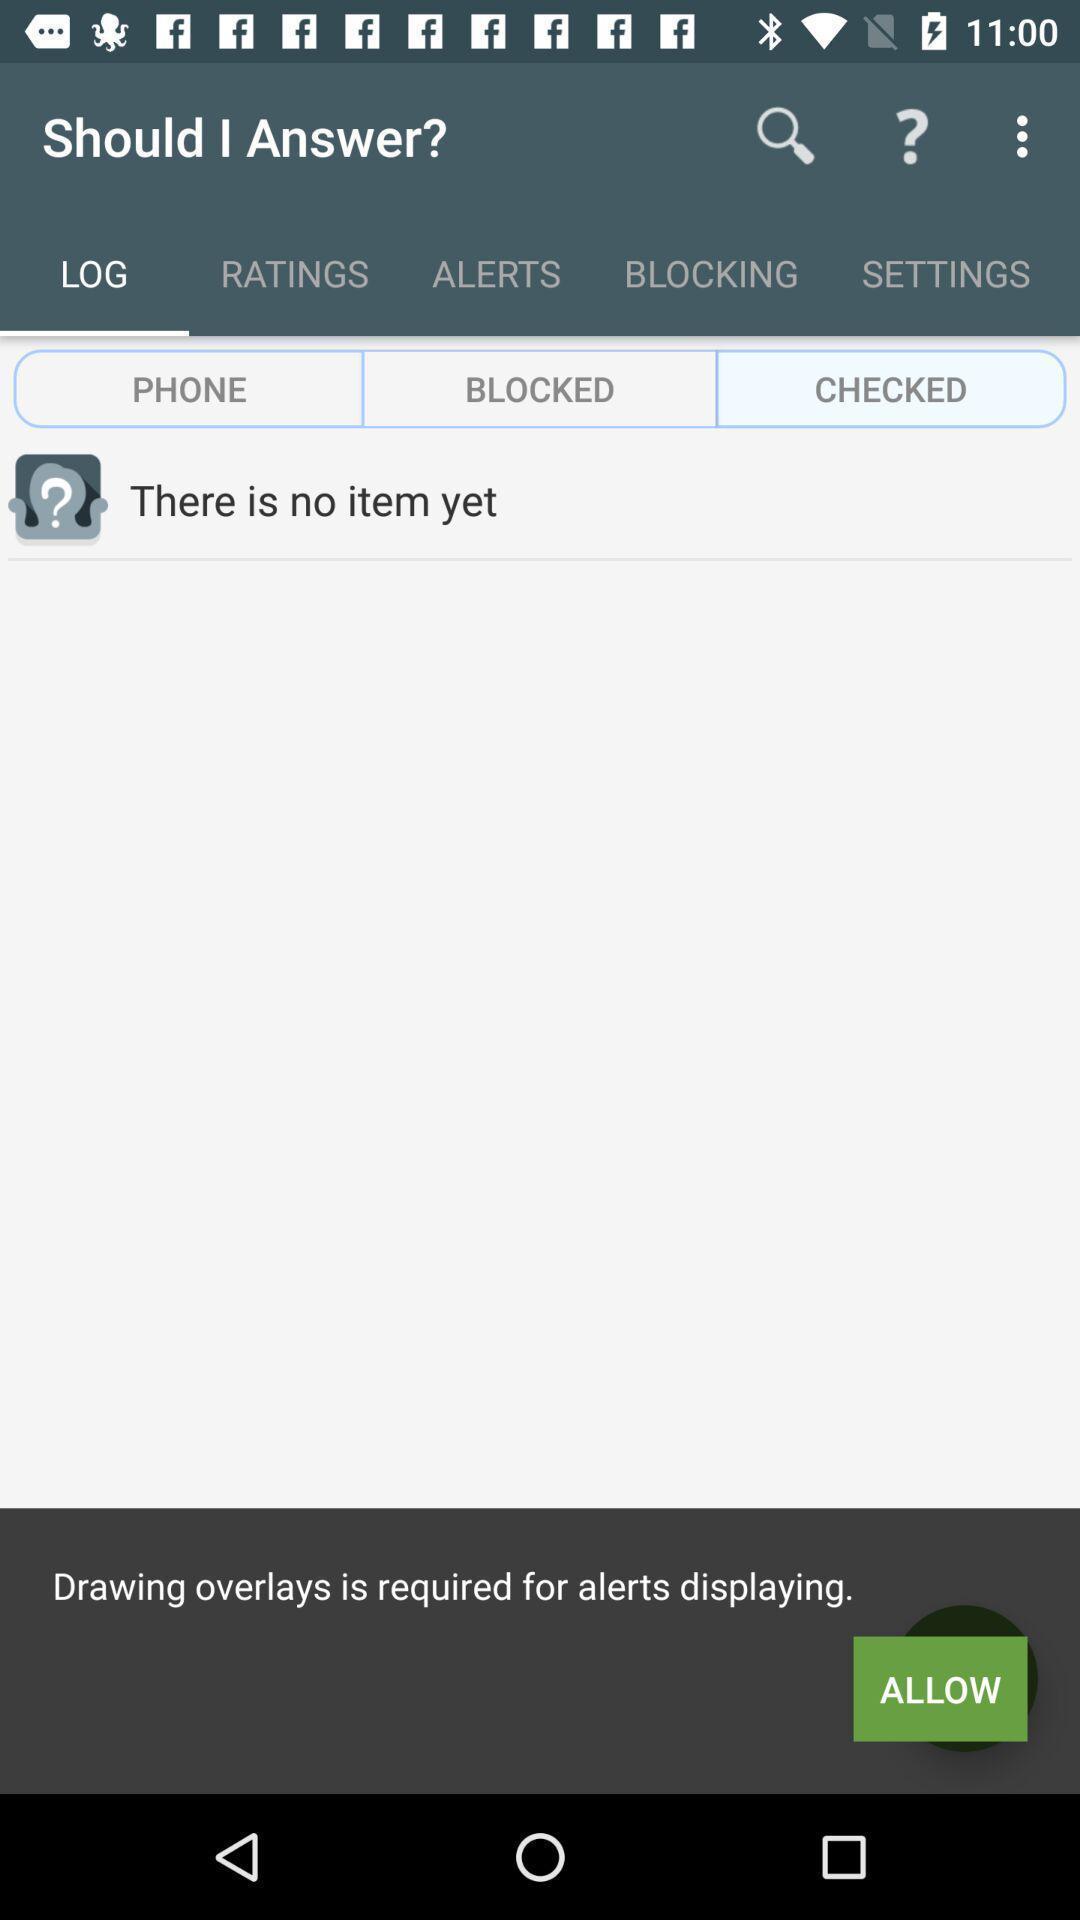Provide a textual representation of this image. Screen shows multiple options. 